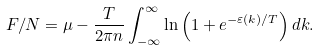<formula> <loc_0><loc_0><loc_500><loc_500>F / N = \mu - \frac { T } { 2 \pi n } \int _ { - \infty } ^ { \infty } \ln \left ( 1 + e ^ { - \varepsilon ( k ) / T } \right ) d k .</formula> 